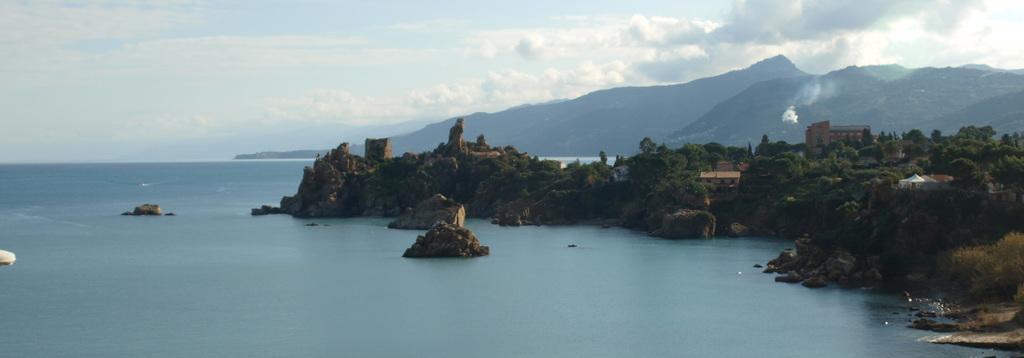Describe this image in one or two sentences. In this picture we can see water, buildings, trees, mountains and in the background we can see the sky with clouds. 